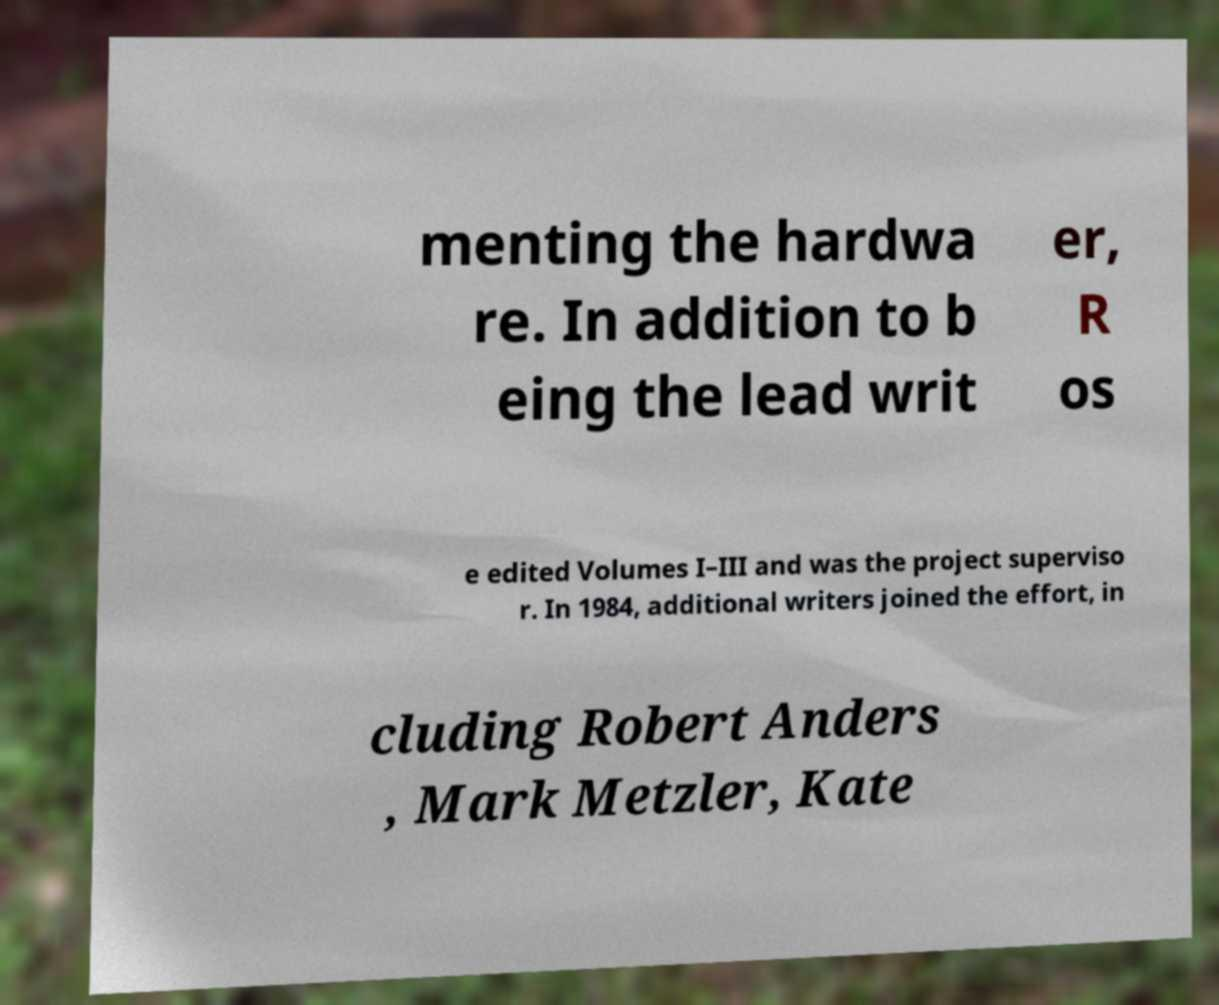Can you accurately transcribe the text from the provided image for me? menting the hardwa re. In addition to b eing the lead writ er, R os e edited Volumes I–III and was the project superviso r. In 1984, additional writers joined the effort, in cluding Robert Anders , Mark Metzler, Kate 